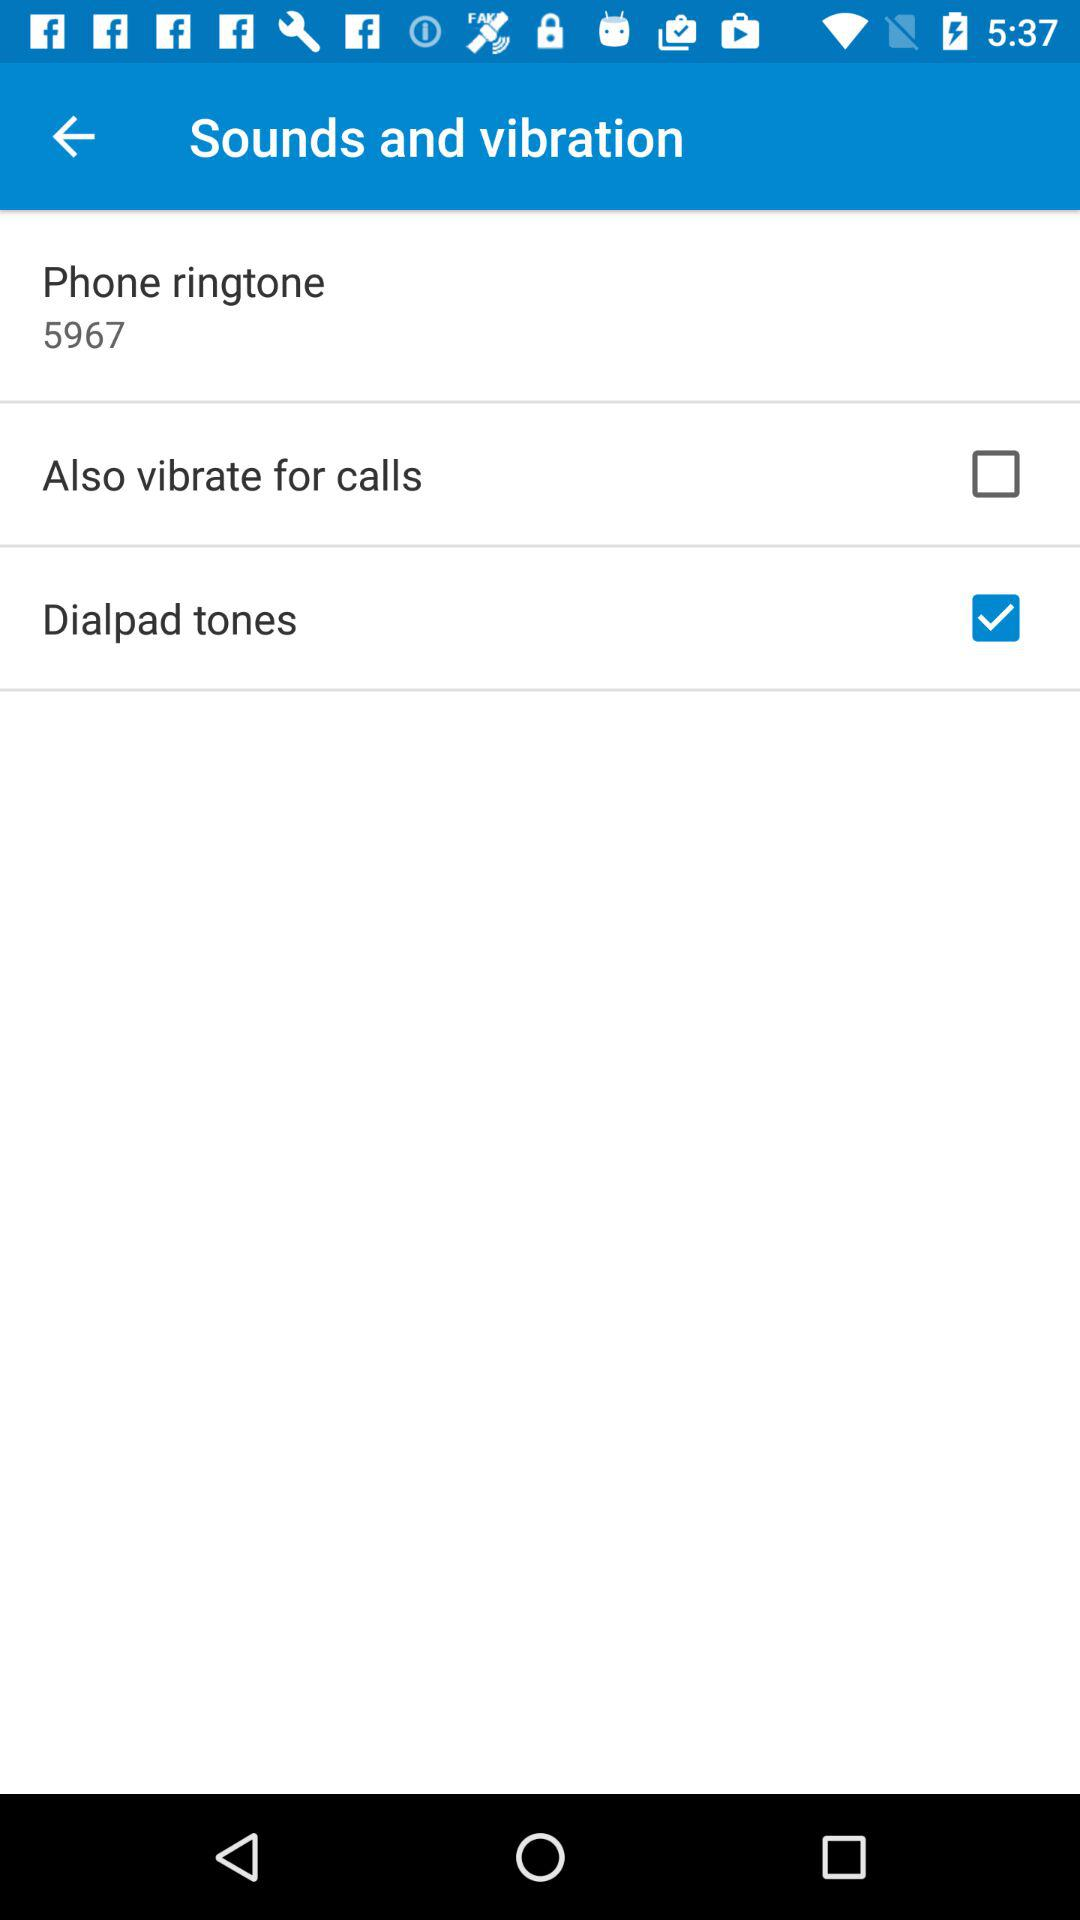What is the phone ringtone? The phone ringtone is 5967. 